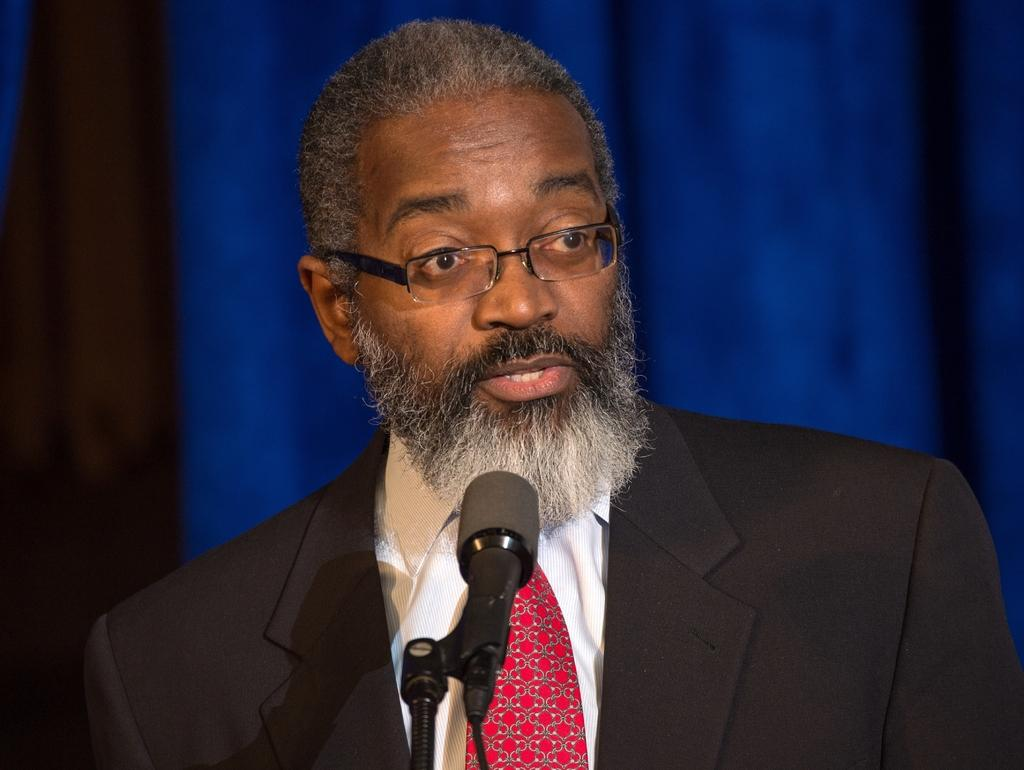What is the person in the image doing? The person is speaking into a microphone. What can be seen in the background of the image? There are blue colored curtains in the image. What type of drain can be seen in the image? There is no drain present in the image. What is the cause of the thunder in the image? There is no thunder present in the image. 